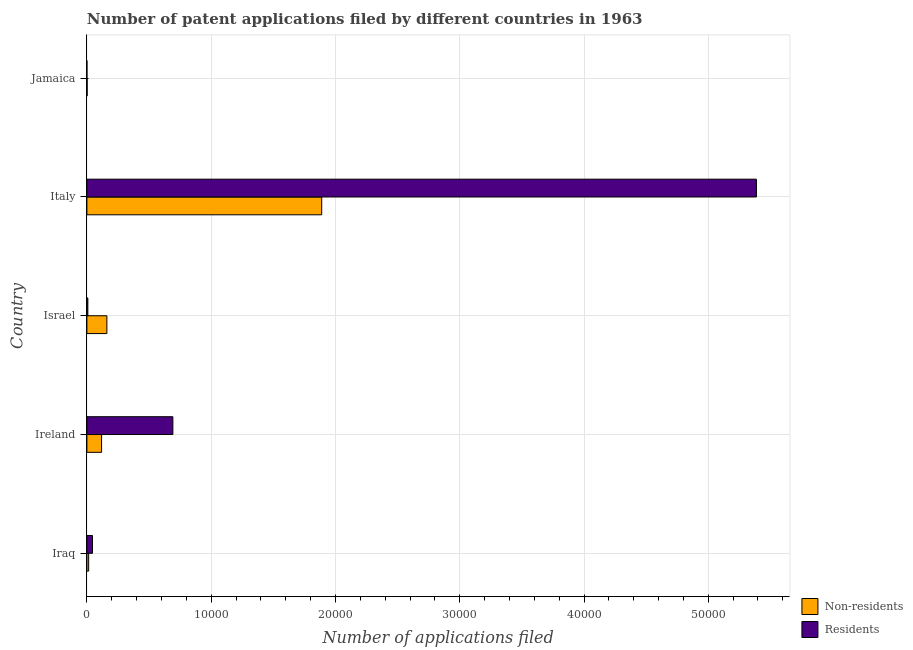How many different coloured bars are there?
Your answer should be compact. 2. How many bars are there on the 2nd tick from the top?
Give a very brief answer. 2. What is the label of the 4th group of bars from the top?
Make the answer very short. Ireland. In how many cases, is the number of bars for a given country not equal to the number of legend labels?
Offer a terse response. 0. What is the number of patent applications by non residents in Jamaica?
Your response must be concise. 21. Across all countries, what is the maximum number of patent applications by residents?
Offer a very short reply. 5.39e+04. Across all countries, what is the minimum number of patent applications by non residents?
Your answer should be compact. 21. In which country was the number of patent applications by residents minimum?
Your answer should be compact. Jamaica. What is the total number of patent applications by residents in the graph?
Your response must be concise. 6.13e+04. What is the difference between the number of patent applications by residents in Iraq and that in Israel?
Offer a terse response. 374. What is the difference between the number of patent applications by residents in Israel and the number of patent applications by non residents in Ireland?
Offer a terse response. -1105. What is the average number of patent applications by residents per country?
Your answer should be compact. 1.23e+04. What is the difference between the number of patent applications by residents and number of patent applications by non residents in Ireland?
Offer a very short reply. 5736. In how many countries, is the number of patent applications by residents greater than 2000 ?
Your answer should be compact. 2. What is the ratio of the number of patent applications by non residents in Italy to that in Jamaica?
Your response must be concise. 899.76. What is the difference between the highest and the second highest number of patent applications by residents?
Your response must be concise. 4.70e+04. What is the difference between the highest and the lowest number of patent applications by residents?
Offer a very short reply. 5.39e+04. Is the sum of the number of patent applications by residents in Ireland and Italy greater than the maximum number of patent applications by non residents across all countries?
Your response must be concise. Yes. What does the 2nd bar from the top in Jamaica represents?
Provide a short and direct response. Non-residents. What does the 1st bar from the bottom in Ireland represents?
Offer a very short reply. Non-residents. How many countries are there in the graph?
Ensure brevity in your answer.  5. What is the difference between two consecutive major ticks on the X-axis?
Ensure brevity in your answer.  10000. How many legend labels are there?
Your answer should be compact. 2. What is the title of the graph?
Provide a short and direct response. Number of patent applications filed by different countries in 1963. What is the label or title of the X-axis?
Provide a succinct answer. Number of applications filed. What is the label or title of the Y-axis?
Keep it short and to the point. Country. What is the Number of applications filed of Non-residents in Iraq?
Give a very brief answer. 142. What is the Number of applications filed in Residents in Iraq?
Your response must be concise. 451. What is the Number of applications filed in Non-residents in Ireland?
Keep it short and to the point. 1182. What is the Number of applications filed of Residents in Ireland?
Make the answer very short. 6918. What is the Number of applications filed of Non-residents in Israel?
Provide a succinct answer. 1608. What is the Number of applications filed of Non-residents in Italy?
Ensure brevity in your answer.  1.89e+04. What is the Number of applications filed of Residents in Italy?
Keep it short and to the point. 5.39e+04. Across all countries, what is the maximum Number of applications filed of Non-residents?
Your response must be concise. 1.89e+04. Across all countries, what is the maximum Number of applications filed of Residents?
Your answer should be very brief. 5.39e+04. Across all countries, what is the minimum Number of applications filed of Non-residents?
Offer a terse response. 21. Across all countries, what is the minimum Number of applications filed of Residents?
Give a very brief answer. 1. What is the total Number of applications filed in Non-residents in the graph?
Ensure brevity in your answer.  2.18e+04. What is the total Number of applications filed in Residents in the graph?
Offer a very short reply. 6.13e+04. What is the difference between the Number of applications filed of Non-residents in Iraq and that in Ireland?
Offer a very short reply. -1040. What is the difference between the Number of applications filed in Residents in Iraq and that in Ireland?
Ensure brevity in your answer.  -6467. What is the difference between the Number of applications filed in Non-residents in Iraq and that in Israel?
Your answer should be very brief. -1466. What is the difference between the Number of applications filed of Residents in Iraq and that in Israel?
Offer a very short reply. 374. What is the difference between the Number of applications filed of Non-residents in Iraq and that in Italy?
Give a very brief answer. -1.88e+04. What is the difference between the Number of applications filed of Residents in Iraq and that in Italy?
Offer a very short reply. -5.34e+04. What is the difference between the Number of applications filed of Non-residents in Iraq and that in Jamaica?
Offer a very short reply. 121. What is the difference between the Number of applications filed in Residents in Iraq and that in Jamaica?
Provide a short and direct response. 450. What is the difference between the Number of applications filed of Non-residents in Ireland and that in Israel?
Your answer should be compact. -426. What is the difference between the Number of applications filed in Residents in Ireland and that in Israel?
Ensure brevity in your answer.  6841. What is the difference between the Number of applications filed in Non-residents in Ireland and that in Italy?
Keep it short and to the point. -1.77e+04. What is the difference between the Number of applications filed of Residents in Ireland and that in Italy?
Ensure brevity in your answer.  -4.70e+04. What is the difference between the Number of applications filed of Non-residents in Ireland and that in Jamaica?
Your answer should be compact. 1161. What is the difference between the Number of applications filed of Residents in Ireland and that in Jamaica?
Ensure brevity in your answer.  6917. What is the difference between the Number of applications filed of Non-residents in Israel and that in Italy?
Offer a very short reply. -1.73e+04. What is the difference between the Number of applications filed in Residents in Israel and that in Italy?
Give a very brief answer. -5.38e+04. What is the difference between the Number of applications filed in Non-residents in Israel and that in Jamaica?
Ensure brevity in your answer.  1587. What is the difference between the Number of applications filed of Residents in Israel and that in Jamaica?
Your answer should be compact. 76. What is the difference between the Number of applications filed in Non-residents in Italy and that in Jamaica?
Your response must be concise. 1.89e+04. What is the difference between the Number of applications filed in Residents in Italy and that in Jamaica?
Provide a succinct answer. 5.39e+04. What is the difference between the Number of applications filed in Non-residents in Iraq and the Number of applications filed in Residents in Ireland?
Your response must be concise. -6776. What is the difference between the Number of applications filed in Non-residents in Iraq and the Number of applications filed in Residents in Israel?
Ensure brevity in your answer.  65. What is the difference between the Number of applications filed of Non-residents in Iraq and the Number of applications filed of Residents in Italy?
Make the answer very short. -5.37e+04. What is the difference between the Number of applications filed in Non-residents in Iraq and the Number of applications filed in Residents in Jamaica?
Provide a short and direct response. 141. What is the difference between the Number of applications filed of Non-residents in Ireland and the Number of applications filed of Residents in Israel?
Provide a succinct answer. 1105. What is the difference between the Number of applications filed in Non-residents in Ireland and the Number of applications filed in Residents in Italy?
Give a very brief answer. -5.27e+04. What is the difference between the Number of applications filed of Non-residents in Ireland and the Number of applications filed of Residents in Jamaica?
Make the answer very short. 1181. What is the difference between the Number of applications filed in Non-residents in Israel and the Number of applications filed in Residents in Italy?
Your answer should be compact. -5.23e+04. What is the difference between the Number of applications filed of Non-residents in Israel and the Number of applications filed of Residents in Jamaica?
Offer a very short reply. 1607. What is the difference between the Number of applications filed of Non-residents in Italy and the Number of applications filed of Residents in Jamaica?
Ensure brevity in your answer.  1.89e+04. What is the average Number of applications filed of Non-residents per country?
Ensure brevity in your answer.  4369.6. What is the average Number of applications filed of Residents per country?
Offer a very short reply. 1.23e+04. What is the difference between the Number of applications filed in Non-residents and Number of applications filed in Residents in Iraq?
Your response must be concise. -309. What is the difference between the Number of applications filed of Non-residents and Number of applications filed of Residents in Ireland?
Your answer should be very brief. -5736. What is the difference between the Number of applications filed in Non-residents and Number of applications filed in Residents in Israel?
Your response must be concise. 1531. What is the difference between the Number of applications filed in Non-residents and Number of applications filed in Residents in Italy?
Offer a very short reply. -3.50e+04. What is the difference between the Number of applications filed of Non-residents and Number of applications filed of Residents in Jamaica?
Provide a succinct answer. 20. What is the ratio of the Number of applications filed of Non-residents in Iraq to that in Ireland?
Your answer should be compact. 0.12. What is the ratio of the Number of applications filed in Residents in Iraq to that in Ireland?
Your response must be concise. 0.07. What is the ratio of the Number of applications filed of Non-residents in Iraq to that in Israel?
Give a very brief answer. 0.09. What is the ratio of the Number of applications filed in Residents in Iraq to that in Israel?
Provide a short and direct response. 5.86. What is the ratio of the Number of applications filed in Non-residents in Iraq to that in Italy?
Give a very brief answer. 0.01. What is the ratio of the Number of applications filed of Residents in Iraq to that in Italy?
Your answer should be very brief. 0.01. What is the ratio of the Number of applications filed of Non-residents in Iraq to that in Jamaica?
Provide a succinct answer. 6.76. What is the ratio of the Number of applications filed in Residents in Iraq to that in Jamaica?
Provide a short and direct response. 451. What is the ratio of the Number of applications filed of Non-residents in Ireland to that in Israel?
Offer a very short reply. 0.74. What is the ratio of the Number of applications filed in Residents in Ireland to that in Israel?
Your answer should be compact. 89.84. What is the ratio of the Number of applications filed of Non-residents in Ireland to that in Italy?
Your response must be concise. 0.06. What is the ratio of the Number of applications filed of Residents in Ireland to that in Italy?
Keep it short and to the point. 0.13. What is the ratio of the Number of applications filed in Non-residents in Ireland to that in Jamaica?
Your response must be concise. 56.29. What is the ratio of the Number of applications filed of Residents in Ireland to that in Jamaica?
Provide a succinct answer. 6918. What is the ratio of the Number of applications filed in Non-residents in Israel to that in Italy?
Your answer should be compact. 0.09. What is the ratio of the Number of applications filed of Residents in Israel to that in Italy?
Provide a short and direct response. 0. What is the ratio of the Number of applications filed in Non-residents in Israel to that in Jamaica?
Give a very brief answer. 76.57. What is the ratio of the Number of applications filed in Non-residents in Italy to that in Jamaica?
Provide a short and direct response. 899.76. What is the ratio of the Number of applications filed of Residents in Italy to that in Jamaica?
Give a very brief answer. 5.39e+04. What is the difference between the highest and the second highest Number of applications filed of Non-residents?
Make the answer very short. 1.73e+04. What is the difference between the highest and the second highest Number of applications filed in Residents?
Make the answer very short. 4.70e+04. What is the difference between the highest and the lowest Number of applications filed in Non-residents?
Your answer should be compact. 1.89e+04. What is the difference between the highest and the lowest Number of applications filed of Residents?
Make the answer very short. 5.39e+04. 